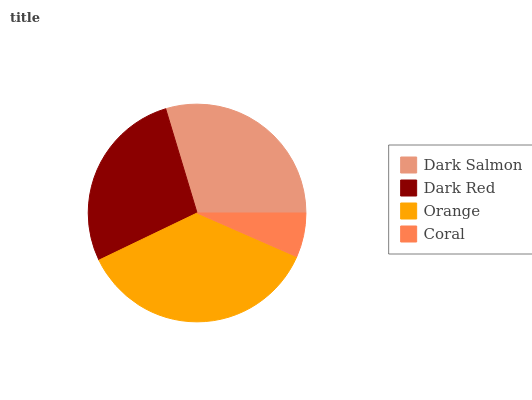Is Coral the minimum?
Answer yes or no. Yes. Is Orange the maximum?
Answer yes or no. Yes. Is Dark Red the minimum?
Answer yes or no. No. Is Dark Red the maximum?
Answer yes or no. No. Is Dark Salmon greater than Dark Red?
Answer yes or no. Yes. Is Dark Red less than Dark Salmon?
Answer yes or no. Yes. Is Dark Red greater than Dark Salmon?
Answer yes or no. No. Is Dark Salmon less than Dark Red?
Answer yes or no. No. Is Dark Salmon the high median?
Answer yes or no. Yes. Is Dark Red the low median?
Answer yes or no. Yes. Is Coral the high median?
Answer yes or no. No. Is Coral the low median?
Answer yes or no. No. 